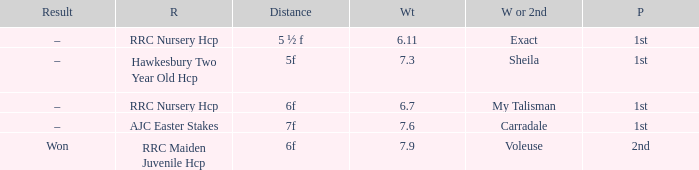What was the name of the winner or 2nd when the result was –, and weight was 6.7? My Talisman. 